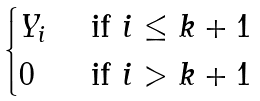<formula> <loc_0><loc_0><loc_500><loc_500>\begin{cases} Y _ { i } & \text { if } i \leq k + 1 \\ 0 & \text { if } i > k + 1 \end{cases}</formula> 